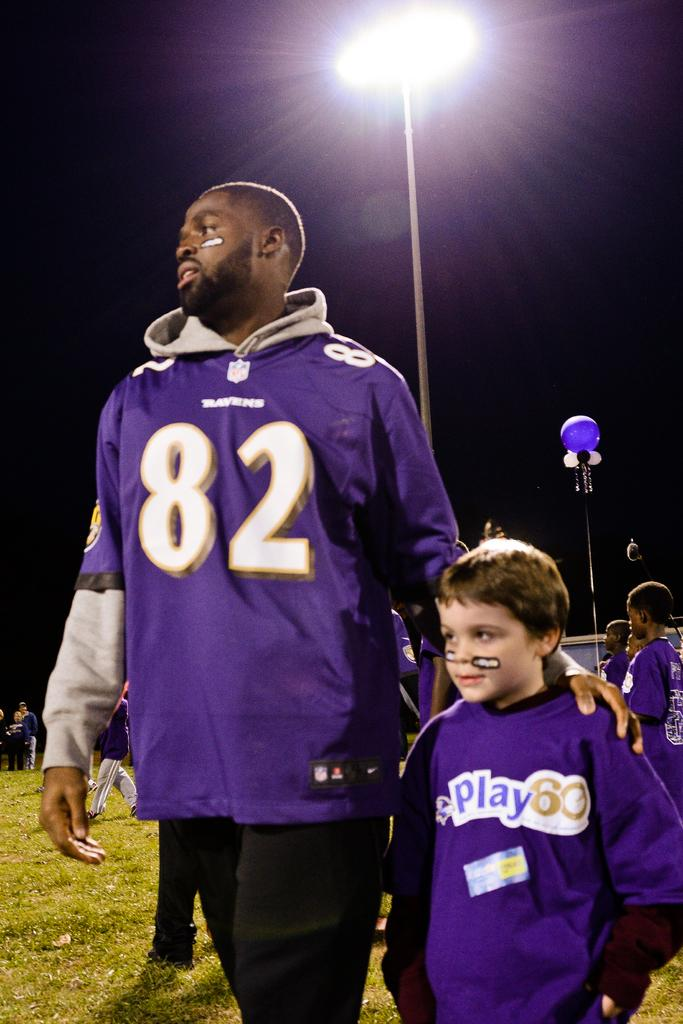Who is present in the image? There is a man and a boy in the image. What are the man and boy doing in the image? The man and boy are standing together on the ground. What can be seen in the background of the image? There are people, light poles, a pole, and a building in the background of the image. What type of beast can be seen interacting with the pole in the background of the image? There is no beast present in the image; it only features a man, a boy, and various background elements. 